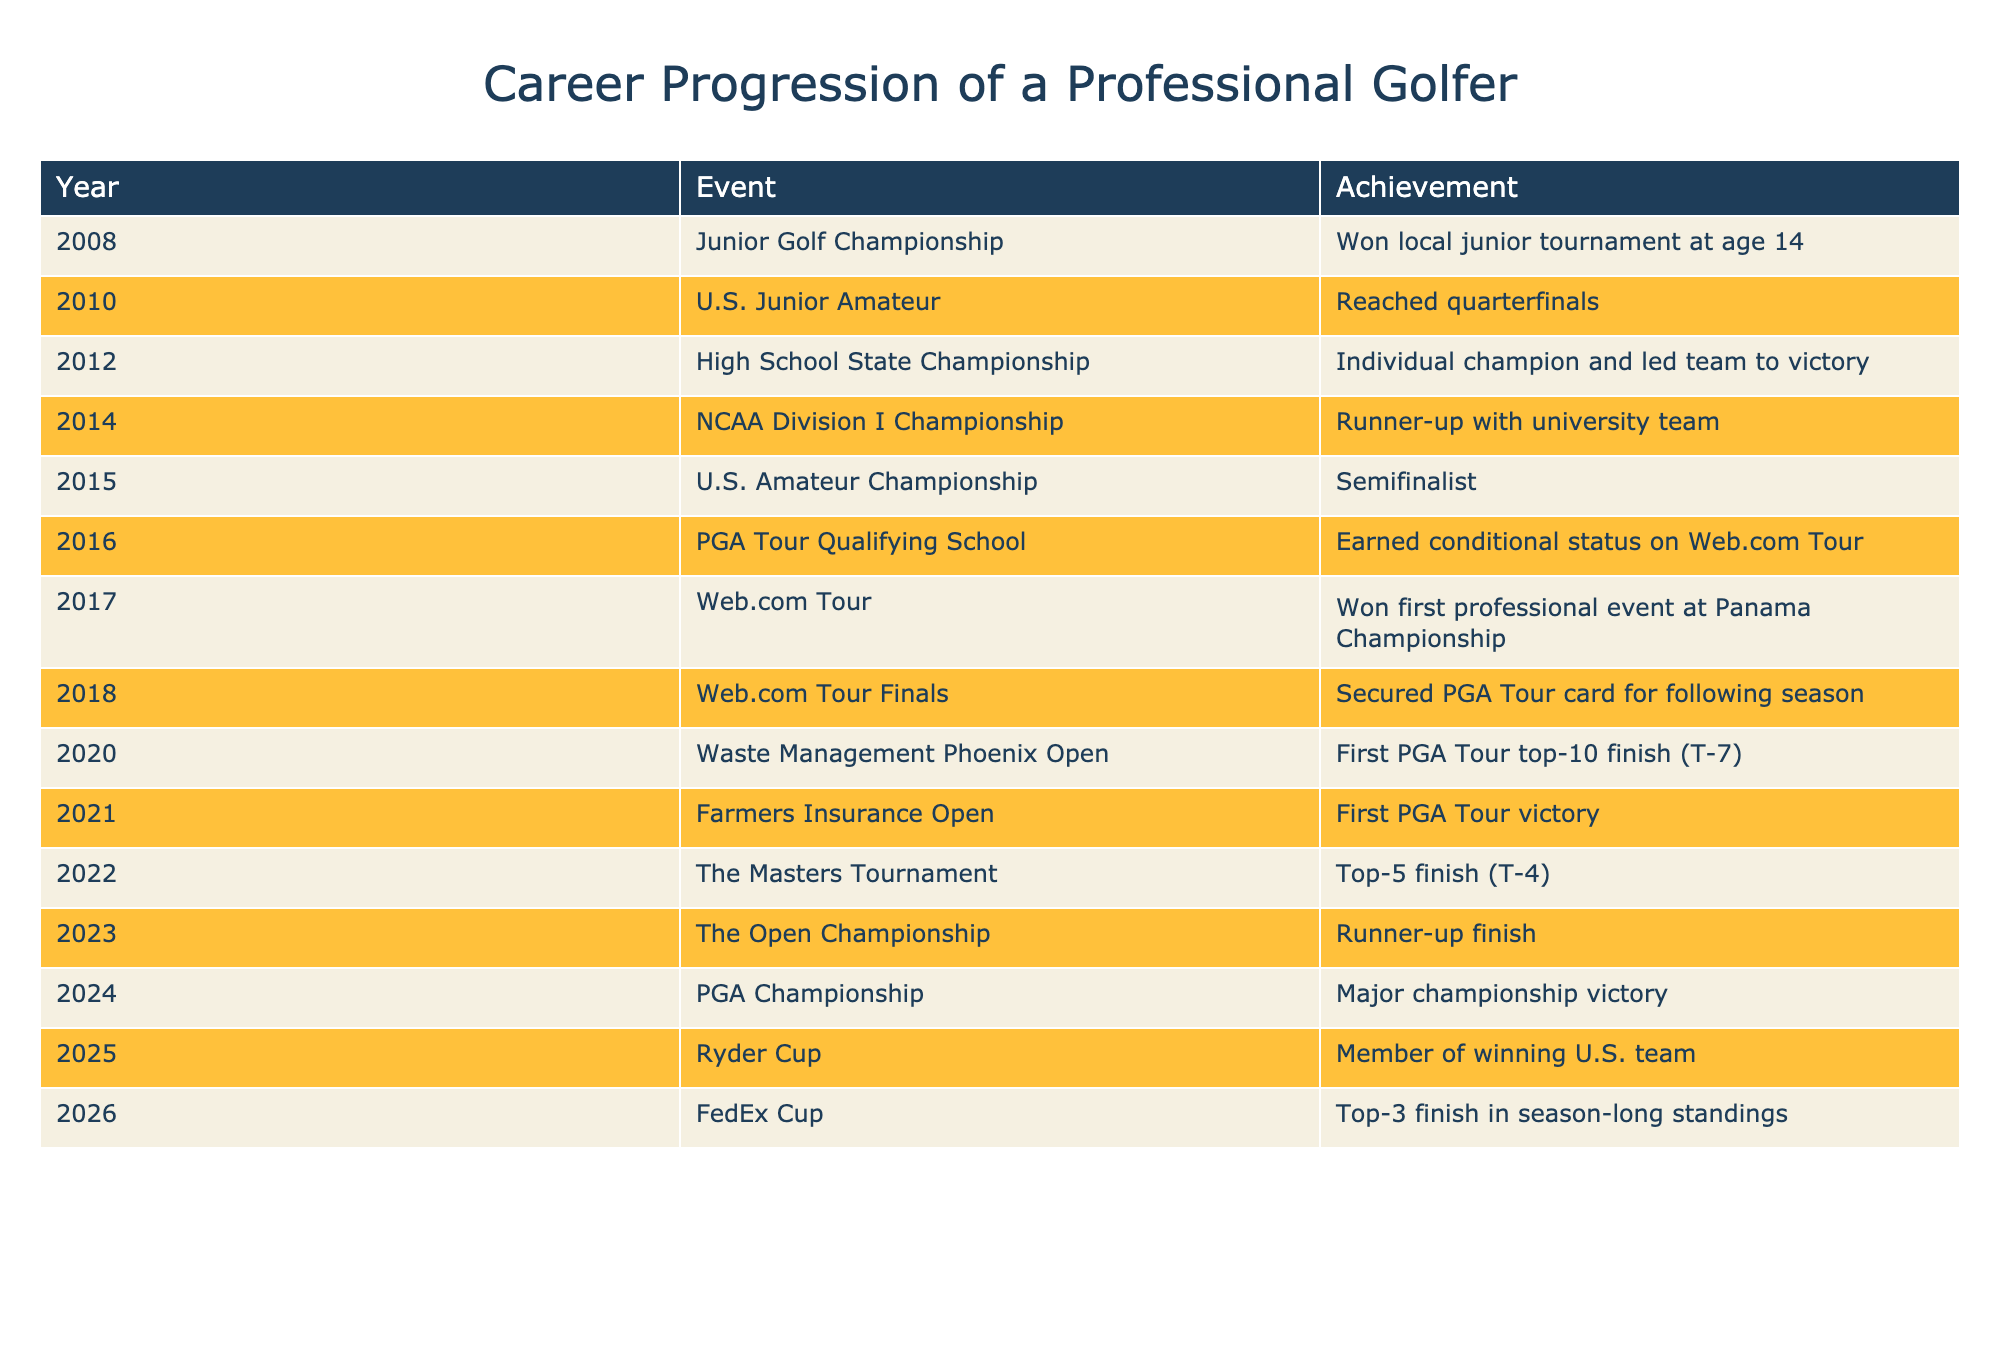What year did the golfer earn conditional status on the Web.com Tour? The table lists the events and achievements by year. In 2016, it states that the golfer earned conditional status on the Web.com Tour.
Answer: 2016 How many events did the golfer win on the Web.com Tour? The table shows that the golfer won their first professional event at the Panama Championship during the Web.com Tour in 2017, but there is no other win listed.
Answer: 1 What was the golfer's achievement in the U.S. Amateur Championship? Referring to the table, in 2015 the golfer was a semifinalist in the U.S. Amateur Championship.
Answer: Semifinalist Did the golfer secure a PGA Tour card before 2020? The table indicates that the golfer secured a PGA Tour card in 2018 during the Web.com Tour Finals, which is before 2020.
Answer: Yes What was the progression of finishes in major tournaments from 2020 to 2024? The finishes from 2020 to 2024 are: 2020 - T-7 in the Waste Management Phoenix Open, 2021 - first victory at the Farmers Insurance Open, 2022 - T-4 in The Masters Tournament, and 2024 - major championship victory in the PGA Championship. This shows a clear upward trajectory in performance.
Answer: Upward trajectory What is the median year in which the golfer achieved a top-10 finish or better? The table shows top finishes or better in 2020 (T-7), 2021 (victory), 2022 (T-4), and 2024 (victory). That’s four achievements, placing them in the years 2020, 2021, 2022, and 2024. When ordered (2020, 2021, 2022, 2024), the median falls between 2021 and 2022, which corresponds to 2021.5.
Answer: 2021.5 How many years did it take from winning the local junior tournament to acquiring the PGA Tour card? The golfer won the local junior tournament in 2008 and secured the PGA Tour card in 2018. Counting the years in between (2018 - 2008), it took 10 years to reach this level.
Answer: 10 years What was the golfer's highest achievement listed for 2024, and how does it compare to prior years? In 2024, the golfer achieved a major championship victory, which is the highest achievement listed. Comparing to previous years where notable finishes included top-5 and a win, this represents the pinnacle of success.
Answer: Major championship victory is the highest 